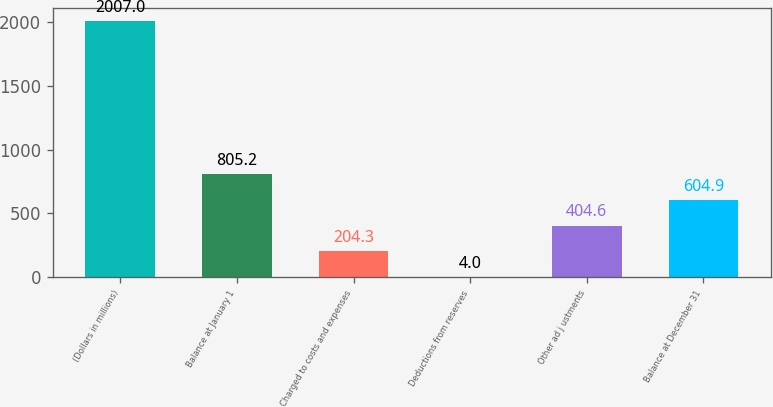Convert chart to OTSL. <chart><loc_0><loc_0><loc_500><loc_500><bar_chart><fcel>(Dollars in millions)<fcel>Balance at January 1<fcel>Charged to costs and expenses<fcel>Deductions from reserves<fcel>Other ad j ustments<fcel>Balance at December 31<nl><fcel>2007<fcel>805.2<fcel>204.3<fcel>4<fcel>404.6<fcel>604.9<nl></chart> 